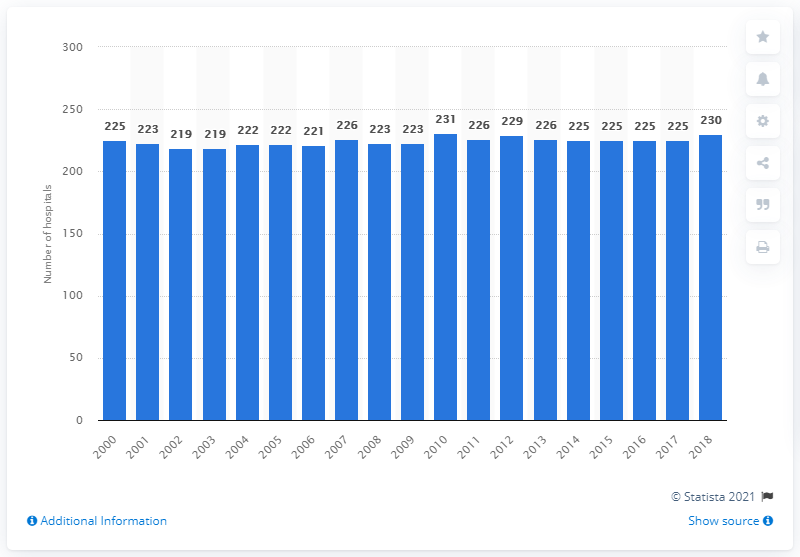Mention a couple of crucial points in this snapshot. In 2018, there were 230 hospitals in Portugal. The number of hospitals in Portugal has been consistently fluctuating, with a slight increase or decrease since 2000. 